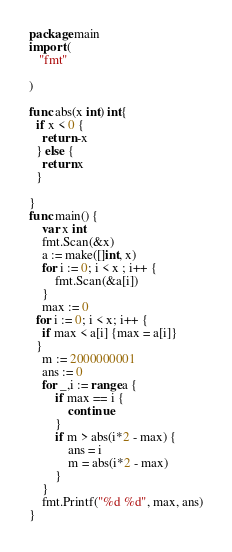<code> <loc_0><loc_0><loc_500><loc_500><_Go_>package main
import (
   "fmt"
   
)

func abs(x int) int{
  if x < 0 {
    return -x
  } else {
    return x
  }
  
}
func main() {
	var x int
	fmt.Scan(&x)
	a := make([]int, x)
	for i := 0; i < x ; i++ {
  		fmt.Scan(&a[i])
	}
	max := 0
  for i := 0; i < x; i++ {
    if max < a[i] {max = a[i]}
  }
	m := 2000000001
	ans := 0
	for _,i := range a {
  		if max == i {
    		continue
    	}
 		if m > abs(i*2 - max) {
    		ans = i
    		m = abs(i*2 - max)
  		}
	}
	fmt.Printf("%d %d", max, ans)
}</code> 